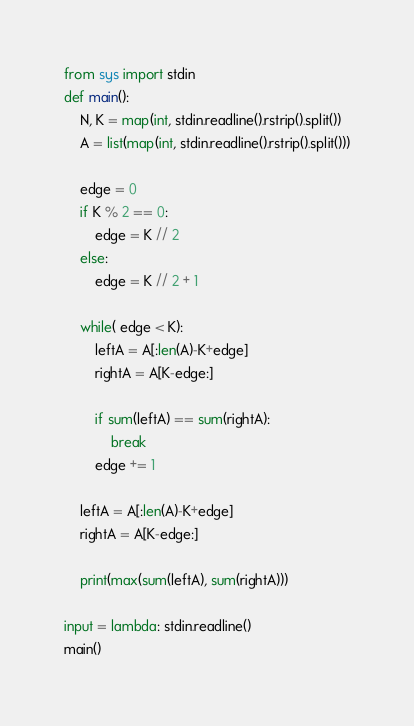<code> <loc_0><loc_0><loc_500><loc_500><_Python_>from sys import stdin
def main():
    N, K = map(int, stdin.readline().rstrip().split())
    A = list(map(int, stdin.readline().rstrip().split()))

    edge = 0
    if K % 2 == 0:
        edge = K // 2
    else:
        edge = K // 2 + 1

    while( edge < K):
        leftA = A[:len(A)-K+edge]
        rightA = A[K-edge:]

        if sum(leftA) == sum(rightA):
            break
        edge += 1

    leftA = A[:len(A)-K+edge]
    rightA = A[K-edge:]

    print(max(sum(leftA), sum(rightA)))

input = lambda: stdin.readline()
main()
</code> 